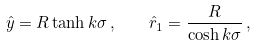Convert formula to latex. <formula><loc_0><loc_0><loc_500><loc_500>\hat { y } = R \tanh k \sigma \, , \quad \hat { r } _ { 1 } = \frac { R } { \cosh k \sigma } \, ,</formula> 